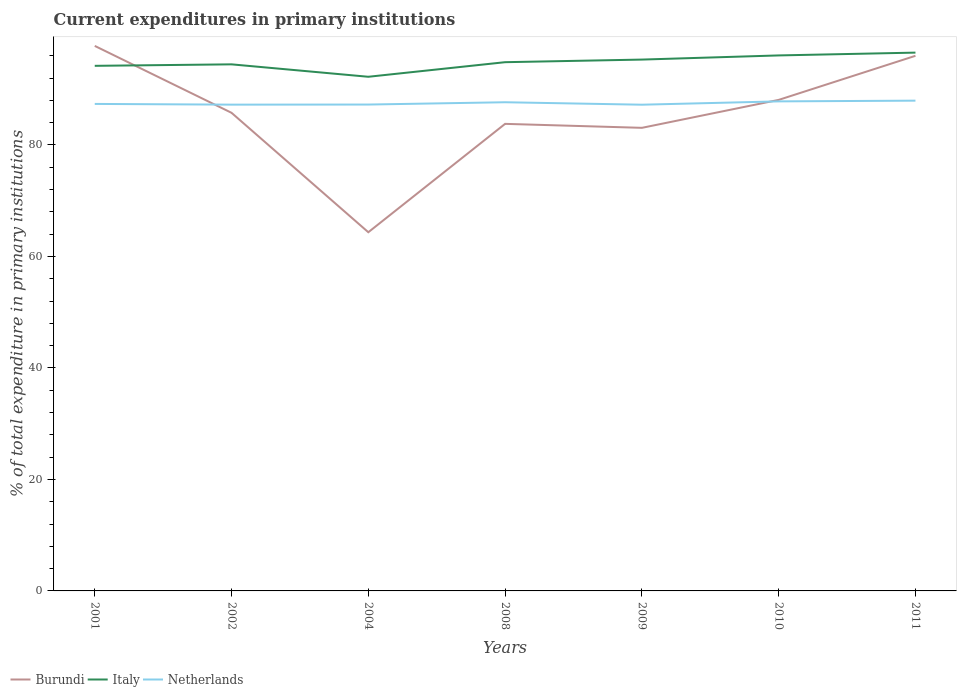Across all years, what is the maximum current expenditures in primary institutions in Burundi?
Give a very brief answer. 64.35. What is the total current expenditures in primary institutions in Burundi in the graph?
Provide a succinct answer. -31.65. What is the difference between the highest and the second highest current expenditures in primary institutions in Italy?
Give a very brief answer. 4.33. How many years are there in the graph?
Offer a terse response. 7. Are the values on the major ticks of Y-axis written in scientific E-notation?
Keep it short and to the point. No. Does the graph contain any zero values?
Provide a short and direct response. No. Does the graph contain grids?
Provide a succinct answer. No. How are the legend labels stacked?
Provide a succinct answer. Horizontal. What is the title of the graph?
Make the answer very short. Current expenditures in primary institutions. What is the label or title of the X-axis?
Offer a very short reply. Years. What is the label or title of the Y-axis?
Your answer should be compact. % of total expenditure in primary institutions. What is the % of total expenditure in primary institutions in Burundi in 2001?
Your answer should be very brief. 97.77. What is the % of total expenditure in primary institutions in Italy in 2001?
Give a very brief answer. 94.2. What is the % of total expenditure in primary institutions of Netherlands in 2001?
Offer a very short reply. 87.36. What is the % of total expenditure in primary institutions of Burundi in 2002?
Provide a short and direct response. 85.77. What is the % of total expenditure in primary institutions of Italy in 2002?
Offer a terse response. 94.46. What is the % of total expenditure in primary institutions in Netherlands in 2002?
Ensure brevity in your answer.  87.24. What is the % of total expenditure in primary institutions of Burundi in 2004?
Your answer should be compact. 64.35. What is the % of total expenditure in primary institutions of Italy in 2004?
Your response must be concise. 92.23. What is the % of total expenditure in primary institutions in Netherlands in 2004?
Your response must be concise. 87.25. What is the % of total expenditure in primary institutions in Burundi in 2008?
Make the answer very short. 83.79. What is the % of total expenditure in primary institutions of Italy in 2008?
Make the answer very short. 94.85. What is the % of total expenditure in primary institutions of Netherlands in 2008?
Offer a very short reply. 87.67. What is the % of total expenditure in primary institutions in Burundi in 2009?
Provide a succinct answer. 83.07. What is the % of total expenditure in primary institutions of Italy in 2009?
Give a very brief answer. 95.32. What is the % of total expenditure in primary institutions in Netherlands in 2009?
Provide a succinct answer. 87.22. What is the % of total expenditure in primary institutions in Burundi in 2010?
Make the answer very short. 88.09. What is the % of total expenditure in primary institutions of Italy in 2010?
Offer a very short reply. 96.07. What is the % of total expenditure in primary institutions in Netherlands in 2010?
Offer a very short reply. 87.82. What is the % of total expenditure in primary institutions in Burundi in 2011?
Offer a very short reply. 96. What is the % of total expenditure in primary institutions of Italy in 2011?
Your answer should be compact. 96.57. What is the % of total expenditure in primary institutions in Netherlands in 2011?
Provide a succinct answer. 87.95. Across all years, what is the maximum % of total expenditure in primary institutions of Burundi?
Give a very brief answer. 97.77. Across all years, what is the maximum % of total expenditure in primary institutions of Italy?
Offer a very short reply. 96.57. Across all years, what is the maximum % of total expenditure in primary institutions in Netherlands?
Provide a short and direct response. 87.95. Across all years, what is the minimum % of total expenditure in primary institutions of Burundi?
Offer a terse response. 64.35. Across all years, what is the minimum % of total expenditure in primary institutions of Italy?
Give a very brief answer. 92.23. Across all years, what is the minimum % of total expenditure in primary institutions in Netherlands?
Provide a short and direct response. 87.22. What is the total % of total expenditure in primary institutions in Burundi in the graph?
Ensure brevity in your answer.  598.84. What is the total % of total expenditure in primary institutions in Italy in the graph?
Keep it short and to the point. 663.7. What is the total % of total expenditure in primary institutions of Netherlands in the graph?
Your answer should be very brief. 612.51. What is the difference between the % of total expenditure in primary institutions of Burundi in 2001 and that in 2002?
Your response must be concise. 12. What is the difference between the % of total expenditure in primary institutions in Italy in 2001 and that in 2002?
Provide a short and direct response. -0.27. What is the difference between the % of total expenditure in primary institutions of Netherlands in 2001 and that in 2002?
Your response must be concise. 0.13. What is the difference between the % of total expenditure in primary institutions in Burundi in 2001 and that in 2004?
Keep it short and to the point. 33.43. What is the difference between the % of total expenditure in primary institutions in Italy in 2001 and that in 2004?
Keep it short and to the point. 1.96. What is the difference between the % of total expenditure in primary institutions of Netherlands in 2001 and that in 2004?
Your answer should be compact. 0.11. What is the difference between the % of total expenditure in primary institutions of Burundi in 2001 and that in 2008?
Provide a short and direct response. 13.99. What is the difference between the % of total expenditure in primary institutions of Italy in 2001 and that in 2008?
Your response must be concise. -0.65. What is the difference between the % of total expenditure in primary institutions in Netherlands in 2001 and that in 2008?
Ensure brevity in your answer.  -0.3. What is the difference between the % of total expenditure in primary institutions in Burundi in 2001 and that in 2009?
Your answer should be compact. 14.7. What is the difference between the % of total expenditure in primary institutions of Italy in 2001 and that in 2009?
Your answer should be very brief. -1.12. What is the difference between the % of total expenditure in primary institutions in Netherlands in 2001 and that in 2009?
Provide a short and direct response. 0.14. What is the difference between the % of total expenditure in primary institutions of Burundi in 2001 and that in 2010?
Give a very brief answer. 9.69. What is the difference between the % of total expenditure in primary institutions in Italy in 2001 and that in 2010?
Offer a very short reply. -1.87. What is the difference between the % of total expenditure in primary institutions in Netherlands in 2001 and that in 2010?
Your response must be concise. -0.46. What is the difference between the % of total expenditure in primary institutions of Burundi in 2001 and that in 2011?
Provide a succinct answer. 1.78. What is the difference between the % of total expenditure in primary institutions in Italy in 2001 and that in 2011?
Give a very brief answer. -2.37. What is the difference between the % of total expenditure in primary institutions in Netherlands in 2001 and that in 2011?
Your answer should be compact. -0.58. What is the difference between the % of total expenditure in primary institutions of Burundi in 2002 and that in 2004?
Ensure brevity in your answer.  21.42. What is the difference between the % of total expenditure in primary institutions of Italy in 2002 and that in 2004?
Give a very brief answer. 2.23. What is the difference between the % of total expenditure in primary institutions in Netherlands in 2002 and that in 2004?
Offer a terse response. -0.02. What is the difference between the % of total expenditure in primary institutions in Burundi in 2002 and that in 2008?
Provide a succinct answer. 1.98. What is the difference between the % of total expenditure in primary institutions of Italy in 2002 and that in 2008?
Give a very brief answer. -0.39. What is the difference between the % of total expenditure in primary institutions of Netherlands in 2002 and that in 2008?
Give a very brief answer. -0.43. What is the difference between the % of total expenditure in primary institutions of Burundi in 2002 and that in 2009?
Keep it short and to the point. 2.7. What is the difference between the % of total expenditure in primary institutions in Italy in 2002 and that in 2009?
Your answer should be compact. -0.85. What is the difference between the % of total expenditure in primary institutions of Netherlands in 2002 and that in 2009?
Offer a very short reply. 0.01. What is the difference between the % of total expenditure in primary institutions in Burundi in 2002 and that in 2010?
Offer a very short reply. -2.32. What is the difference between the % of total expenditure in primary institutions in Italy in 2002 and that in 2010?
Ensure brevity in your answer.  -1.6. What is the difference between the % of total expenditure in primary institutions of Netherlands in 2002 and that in 2010?
Offer a terse response. -0.59. What is the difference between the % of total expenditure in primary institutions of Burundi in 2002 and that in 2011?
Your answer should be very brief. -10.22. What is the difference between the % of total expenditure in primary institutions of Italy in 2002 and that in 2011?
Make the answer very short. -2.1. What is the difference between the % of total expenditure in primary institutions of Netherlands in 2002 and that in 2011?
Your response must be concise. -0.71. What is the difference between the % of total expenditure in primary institutions in Burundi in 2004 and that in 2008?
Your answer should be compact. -19.44. What is the difference between the % of total expenditure in primary institutions in Italy in 2004 and that in 2008?
Provide a short and direct response. -2.62. What is the difference between the % of total expenditure in primary institutions in Netherlands in 2004 and that in 2008?
Make the answer very short. -0.41. What is the difference between the % of total expenditure in primary institutions of Burundi in 2004 and that in 2009?
Ensure brevity in your answer.  -18.73. What is the difference between the % of total expenditure in primary institutions in Italy in 2004 and that in 2009?
Offer a terse response. -3.08. What is the difference between the % of total expenditure in primary institutions of Netherlands in 2004 and that in 2009?
Provide a short and direct response. 0.03. What is the difference between the % of total expenditure in primary institutions of Burundi in 2004 and that in 2010?
Give a very brief answer. -23.74. What is the difference between the % of total expenditure in primary institutions of Italy in 2004 and that in 2010?
Offer a terse response. -3.83. What is the difference between the % of total expenditure in primary institutions in Netherlands in 2004 and that in 2010?
Your response must be concise. -0.57. What is the difference between the % of total expenditure in primary institutions of Burundi in 2004 and that in 2011?
Your answer should be compact. -31.65. What is the difference between the % of total expenditure in primary institutions of Italy in 2004 and that in 2011?
Your answer should be very brief. -4.33. What is the difference between the % of total expenditure in primary institutions in Netherlands in 2004 and that in 2011?
Provide a succinct answer. -0.7. What is the difference between the % of total expenditure in primary institutions in Burundi in 2008 and that in 2009?
Your response must be concise. 0.71. What is the difference between the % of total expenditure in primary institutions in Italy in 2008 and that in 2009?
Provide a short and direct response. -0.47. What is the difference between the % of total expenditure in primary institutions in Netherlands in 2008 and that in 2009?
Give a very brief answer. 0.44. What is the difference between the % of total expenditure in primary institutions in Burundi in 2008 and that in 2010?
Your answer should be compact. -4.3. What is the difference between the % of total expenditure in primary institutions of Italy in 2008 and that in 2010?
Make the answer very short. -1.21. What is the difference between the % of total expenditure in primary institutions in Netherlands in 2008 and that in 2010?
Provide a succinct answer. -0.16. What is the difference between the % of total expenditure in primary institutions of Burundi in 2008 and that in 2011?
Your answer should be very brief. -12.21. What is the difference between the % of total expenditure in primary institutions of Italy in 2008 and that in 2011?
Your response must be concise. -1.72. What is the difference between the % of total expenditure in primary institutions in Netherlands in 2008 and that in 2011?
Offer a terse response. -0.28. What is the difference between the % of total expenditure in primary institutions of Burundi in 2009 and that in 2010?
Your answer should be compact. -5.01. What is the difference between the % of total expenditure in primary institutions of Italy in 2009 and that in 2010?
Provide a short and direct response. -0.75. What is the difference between the % of total expenditure in primary institutions in Netherlands in 2009 and that in 2010?
Give a very brief answer. -0.6. What is the difference between the % of total expenditure in primary institutions of Burundi in 2009 and that in 2011?
Keep it short and to the point. -12.92. What is the difference between the % of total expenditure in primary institutions of Italy in 2009 and that in 2011?
Keep it short and to the point. -1.25. What is the difference between the % of total expenditure in primary institutions of Netherlands in 2009 and that in 2011?
Offer a very short reply. -0.73. What is the difference between the % of total expenditure in primary institutions of Burundi in 2010 and that in 2011?
Offer a very short reply. -7.91. What is the difference between the % of total expenditure in primary institutions of Italy in 2010 and that in 2011?
Your answer should be compact. -0.5. What is the difference between the % of total expenditure in primary institutions in Netherlands in 2010 and that in 2011?
Your answer should be compact. -0.13. What is the difference between the % of total expenditure in primary institutions of Burundi in 2001 and the % of total expenditure in primary institutions of Italy in 2002?
Your answer should be compact. 3.31. What is the difference between the % of total expenditure in primary institutions in Burundi in 2001 and the % of total expenditure in primary institutions in Netherlands in 2002?
Keep it short and to the point. 10.54. What is the difference between the % of total expenditure in primary institutions of Italy in 2001 and the % of total expenditure in primary institutions of Netherlands in 2002?
Provide a short and direct response. 6.96. What is the difference between the % of total expenditure in primary institutions of Burundi in 2001 and the % of total expenditure in primary institutions of Italy in 2004?
Offer a terse response. 5.54. What is the difference between the % of total expenditure in primary institutions in Burundi in 2001 and the % of total expenditure in primary institutions in Netherlands in 2004?
Offer a terse response. 10.52. What is the difference between the % of total expenditure in primary institutions in Italy in 2001 and the % of total expenditure in primary institutions in Netherlands in 2004?
Keep it short and to the point. 6.95. What is the difference between the % of total expenditure in primary institutions of Burundi in 2001 and the % of total expenditure in primary institutions of Italy in 2008?
Provide a succinct answer. 2.92. What is the difference between the % of total expenditure in primary institutions of Burundi in 2001 and the % of total expenditure in primary institutions of Netherlands in 2008?
Your response must be concise. 10.11. What is the difference between the % of total expenditure in primary institutions in Italy in 2001 and the % of total expenditure in primary institutions in Netherlands in 2008?
Provide a succinct answer. 6.53. What is the difference between the % of total expenditure in primary institutions of Burundi in 2001 and the % of total expenditure in primary institutions of Italy in 2009?
Offer a very short reply. 2.46. What is the difference between the % of total expenditure in primary institutions of Burundi in 2001 and the % of total expenditure in primary institutions of Netherlands in 2009?
Your answer should be very brief. 10.55. What is the difference between the % of total expenditure in primary institutions in Italy in 2001 and the % of total expenditure in primary institutions in Netherlands in 2009?
Provide a succinct answer. 6.97. What is the difference between the % of total expenditure in primary institutions in Burundi in 2001 and the % of total expenditure in primary institutions in Italy in 2010?
Your answer should be very brief. 1.71. What is the difference between the % of total expenditure in primary institutions in Burundi in 2001 and the % of total expenditure in primary institutions in Netherlands in 2010?
Your answer should be very brief. 9.95. What is the difference between the % of total expenditure in primary institutions of Italy in 2001 and the % of total expenditure in primary institutions of Netherlands in 2010?
Give a very brief answer. 6.38. What is the difference between the % of total expenditure in primary institutions of Burundi in 2001 and the % of total expenditure in primary institutions of Italy in 2011?
Your answer should be compact. 1.21. What is the difference between the % of total expenditure in primary institutions in Burundi in 2001 and the % of total expenditure in primary institutions in Netherlands in 2011?
Ensure brevity in your answer.  9.82. What is the difference between the % of total expenditure in primary institutions of Italy in 2001 and the % of total expenditure in primary institutions of Netherlands in 2011?
Offer a terse response. 6.25. What is the difference between the % of total expenditure in primary institutions of Burundi in 2002 and the % of total expenditure in primary institutions of Italy in 2004?
Provide a short and direct response. -6.46. What is the difference between the % of total expenditure in primary institutions of Burundi in 2002 and the % of total expenditure in primary institutions of Netherlands in 2004?
Give a very brief answer. -1.48. What is the difference between the % of total expenditure in primary institutions of Italy in 2002 and the % of total expenditure in primary institutions of Netherlands in 2004?
Give a very brief answer. 7.21. What is the difference between the % of total expenditure in primary institutions in Burundi in 2002 and the % of total expenditure in primary institutions in Italy in 2008?
Give a very brief answer. -9.08. What is the difference between the % of total expenditure in primary institutions of Burundi in 2002 and the % of total expenditure in primary institutions of Netherlands in 2008?
Provide a short and direct response. -1.89. What is the difference between the % of total expenditure in primary institutions of Italy in 2002 and the % of total expenditure in primary institutions of Netherlands in 2008?
Offer a very short reply. 6.8. What is the difference between the % of total expenditure in primary institutions in Burundi in 2002 and the % of total expenditure in primary institutions in Italy in 2009?
Keep it short and to the point. -9.55. What is the difference between the % of total expenditure in primary institutions of Burundi in 2002 and the % of total expenditure in primary institutions of Netherlands in 2009?
Your answer should be very brief. -1.45. What is the difference between the % of total expenditure in primary institutions in Italy in 2002 and the % of total expenditure in primary institutions in Netherlands in 2009?
Offer a terse response. 7.24. What is the difference between the % of total expenditure in primary institutions of Burundi in 2002 and the % of total expenditure in primary institutions of Italy in 2010?
Offer a terse response. -10.29. What is the difference between the % of total expenditure in primary institutions in Burundi in 2002 and the % of total expenditure in primary institutions in Netherlands in 2010?
Your answer should be very brief. -2.05. What is the difference between the % of total expenditure in primary institutions in Italy in 2002 and the % of total expenditure in primary institutions in Netherlands in 2010?
Your answer should be compact. 6.64. What is the difference between the % of total expenditure in primary institutions in Burundi in 2002 and the % of total expenditure in primary institutions in Italy in 2011?
Your answer should be compact. -10.8. What is the difference between the % of total expenditure in primary institutions in Burundi in 2002 and the % of total expenditure in primary institutions in Netherlands in 2011?
Provide a succinct answer. -2.18. What is the difference between the % of total expenditure in primary institutions of Italy in 2002 and the % of total expenditure in primary institutions of Netherlands in 2011?
Provide a succinct answer. 6.52. What is the difference between the % of total expenditure in primary institutions of Burundi in 2004 and the % of total expenditure in primary institutions of Italy in 2008?
Provide a short and direct response. -30.5. What is the difference between the % of total expenditure in primary institutions of Burundi in 2004 and the % of total expenditure in primary institutions of Netherlands in 2008?
Provide a succinct answer. -23.32. What is the difference between the % of total expenditure in primary institutions in Italy in 2004 and the % of total expenditure in primary institutions in Netherlands in 2008?
Provide a short and direct response. 4.57. What is the difference between the % of total expenditure in primary institutions of Burundi in 2004 and the % of total expenditure in primary institutions of Italy in 2009?
Provide a short and direct response. -30.97. What is the difference between the % of total expenditure in primary institutions in Burundi in 2004 and the % of total expenditure in primary institutions in Netherlands in 2009?
Your answer should be compact. -22.88. What is the difference between the % of total expenditure in primary institutions in Italy in 2004 and the % of total expenditure in primary institutions in Netherlands in 2009?
Your answer should be compact. 5.01. What is the difference between the % of total expenditure in primary institutions of Burundi in 2004 and the % of total expenditure in primary institutions of Italy in 2010?
Give a very brief answer. -31.72. What is the difference between the % of total expenditure in primary institutions of Burundi in 2004 and the % of total expenditure in primary institutions of Netherlands in 2010?
Your answer should be very brief. -23.47. What is the difference between the % of total expenditure in primary institutions in Italy in 2004 and the % of total expenditure in primary institutions in Netherlands in 2010?
Your response must be concise. 4.41. What is the difference between the % of total expenditure in primary institutions in Burundi in 2004 and the % of total expenditure in primary institutions in Italy in 2011?
Ensure brevity in your answer.  -32.22. What is the difference between the % of total expenditure in primary institutions of Burundi in 2004 and the % of total expenditure in primary institutions of Netherlands in 2011?
Offer a terse response. -23.6. What is the difference between the % of total expenditure in primary institutions in Italy in 2004 and the % of total expenditure in primary institutions in Netherlands in 2011?
Give a very brief answer. 4.28. What is the difference between the % of total expenditure in primary institutions in Burundi in 2008 and the % of total expenditure in primary institutions in Italy in 2009?
Your answer should be compact. -11.53. What is the difference between the % of total expenditure in primary institutions in Burundi in 2008 and the % of total expenditure in primary institutions in Netherlands in 2009?
Ensure brevity in your answer.  -3.44. What is the difference between the % of total expenditure in primary institutions of Italy in 2008 and the % of total expenditure in primary institutions of Netherlands in 2009?
Ensure brevity in your answer.  7.63. What is the difference between the % of total expenditure in primary institutions of Burundi in 2008 and the % of total expenditure in primary institutions of Italy in 2010?
Make the answer very short. -12.28. What is the difference between the % of total expenditure in primary institutions of Burundi in 2008 and the % of total expenditure in primary institutions of Netherlands in 2010?
Your answer should be very brief. -4.03. What is the difference between the % of total expenditure in primary institutions in Italy in 2008 and the % of total expenditure in primary institutions in Netherlands in 2010?
Give a very brief answer. 7.03. What is the difference between the % of total expenditure in primary institutions in Burundi in 2008 and the % of total expenditure in primary institutions in Italy in 2011?
Your answer should be compact. -12.78. What is the difference between the % of total expenditure in primary institutions of Burundi in 2008 and the % of total expenditure in primary institutions of Netherlands in 2011?
Your answer should be compact. -4.16. What is the difference between the % of total expenditure in primary institutions of Italy in 2008 and the % of total expenditure in primary institutions of Netherlands in 2011?
Your answer should be very brief. 6.9. What is the difference between the % of total expenditure in primary institutions of Burundi in 2009 and the % of total expenditure in primary institutions of Italy in 2010?
Your response must be concise. -12.99. What is the difference between the % of total expenditure in primary institutions of Burundi in 2009 and the % of total expenditure in primary institutions of Netherlands in 2010?
Offer a very short reply. -4.75. What is the difference between the % of total expenditure in primary institutions in Italy in 2009 and the % of total expenditure in primary institutions in Netherlands in 2010?
Give a very brief answer. 7.5. What is the difference between the % of total expenditure in primary institutions of Burundi in 2009 and the % of total expenditure in primary institutions of Italy in 2011?
Make the answer very short. -13.49. What is the difference between the % of total expenditure in primary institutions in Burundi in 2009 and the % of total expenditure in primary institutions in Netherlands in 2011?
Give a very brief answer. -4.87. What is the difference between the % of total expenditure in primary institutions in Italy in 2009 and the % of total expenditure in primary institutions in Netherlands in 2011?
Provide a short and direct response. 7.37. What is the difference between the % of total expenditure in primary institutions in Burundi in 2010 and the % of total expenditure in primary institutions in Italy in 2011?
Provide a short and direct response. -8.48. What is the difference between the % of total expenditure in primary institutions in Burundi in 2010 and the % of total expenditure in primary institutions in Netherlands in 2011?
Provide a succinct answer. 0.14. What is the difference between the % of total expenditure in primary institutions of Italy in 2010 and the % of total expenditure in primary institutions of Netherlands in 2011?
Provide a short and direct response. 8.12. What is the average % of total expenditure in primary institutions in Burundi per year?
Offer a very short reply. 85.55. What is the average % of total expenditure in primary institutions of Italy per year?
Offer a very short reply. 94.81. What is the average % of total expenditure in primary institutions of Netherlands per year?
Provide a short and direct response. 87.5. In the year 2001, what is the difference between the % of total expenditure in primary institutions in Burundi and % of total expenditure in primary institutions in Italy?
Offer a very short reply. 3.58. In the year 2001, what is the difference between the % of total expenditure in primary institutions in Burundi and % of total expenditure in primary institutions in Netherlands?
Offer a very short reply. 10.41. In the year 2001, what is the difference between the % of total expenditure in primary institutions in Italy and % of total expenditure in primary institutions in Netherlands?
Give a very brief answer. 6.83. In the year 2002, what is the difference between the % of total expenditure in primary institutions in Burundi and % of total expenditure in primary institutions in Italy?
Ensure brevity in your answer.  -8.69. In the year 2002, what is the difference between the % of total expenditure in primary institutions of Burundi and % of total expenditure in primary institutions of Netherlands?
Offer a very short reply. -1.46. In the year 2002, what is the difference between the % of total expenditure in primary institutions in Italy and % of total expenditure in primary institutions in Netherlands?
Give a very brief answer. 7.23. In the year 2004, what is the difference between the % of total expenditure in primary institutions of Burundi and % of total expenditure in primary institutions of Italy?
Make the answer very short. -27.89. In the year 2004, what is the difference between the % of total expenditure in primary institutions of Burundi and % of total expenditure in primary institutions of Netherlands?
Your answer should be compact. -22.9. In the year 2004, what is the difference between the % of total expenditure in primary institutions in Italy and % of total expenditure in primary institutions in Netherlands?
Offer a very short reply. 4.98. In the year 2008, what is the difference between the % of total expenditure in primary institutions in Burundi and % of total expenditure in primary institutions in Italy?
Make the answer very short. -11.06. In the year 2008, what is the difference between the % of total expenditure in primary institutions in Burundi and % of total expenditure in primary institutions in Netherlands?
Provide a succinct answer. -3.88. In the year 2008, what is the difference between the % of total expenditure in primary institutions in Italy and % of total expenditure in primary institutions in Netherlands?
Provide a short and direct response. 7.19. In the year 2009, what is the difference between the % of total expenditure in primary institutions of Burundi and % of total expenditure in primary institutions of Italy?
Keep it short and to the point. -12.24. In the year 2009, what is the difference between the % of total expenditure in primary institutions in Burundi and % of total expenditure in primary institutions in Netherlands?
Provide a succinct answer. -4.15. In the year 2009, what is the difference between the % of total expenditure in primary institutions of Italy and % of total expenditure in primary institutions of Netherlands?
Keep it short and to the point. 8.09. In the year 2010, what is the difference between the % of total expenditure in primary institutions of Burundi and % of total expenditure in primary institutions of Italy?
Offer a terse response. -7.98. In the year 2010, what is the difference between the % of total expenditure in primary institutions in Burundi and % of total expenditure in primary institutions in Netherlands?
Keep it short and to the point. 0.27. In the year 2010, what is the difference between the % of total expenditure in primary institutions of Italy and % of total expenditure in primary institutions of Netherlands?
Ensure brevity in your answer.  8.24. In the year 2011, what is the difference between the % of total expenditure in primary institutions in Burundi and % of total expenditure in primary institutions in Italy?
Make the answer very short. -0.57. In the year 2011, what is the difference between the % of total expenditure in primary institutions of Burundi and % of total expenditure in primary institutions of Netherlands?
Your answer should be very brief. 8.05. In the year 2011, what is the difference between the % of total expenditure in primary institutions of Italy and % of total expenditure in primary institutions of Netherlands?
Your answer should be very brief. 8.62. What is the ratio of the % of total expenditure in primary institutions of Burundi in 2001 to that in 2002?
Give a very brief answer. 1.14. What is the ratio of the % of total expenditure in primary institutions of Netherlands in 2001 to that in 2002?
Make the answer very short. 1. What is the ratio of the % of total expenditure in primary institutions in Burundi in 2001 to that in 2004?
Make the answer very short. 1.52. What is the ratio of the % of total expenditure in primary institutions in Italy in 2001 to that in 2004?
Provide a succinct answer. 1.02. What is the ratio of the % of total expenditure in primary institutions in Netherlands in 2001 to that in 2004?
Ensure brevity in your answer.  1. What is the ratio of the % of total expenditure in primary institutions in Burundi in 2001 to that in 2008?
Offer a very short reply. 1.17. What is the ratio of the % of total expenditure in primary institutions of Italy in 2001 to that in 2008?
Offer a very short reply. 0.99. What is the ratio of the % of total expenditure in primary institutions in Burundi in 2001 to that in 2009?
Your answer should be very brief. 1.18. What is the ratio of the % of total expenditure in primary institutions in Italy in 2001 to that in 2009?
Provide a short and direct response. 0.99. What is the ratio of the % of total expenditure in primary institutions in Burundi in 2001 to that in 2010?
Give a very brief answer. 1.11. What is the ratio of the % of total expenditure in primary institutions in Italy in 2001 to that in 2010?
Keep it short and to the point. 0.98. What is the ratio of the % of total expenditure in primary institutions of Burundi in 2001 to that in 2011?
Provide a short and direct response. 1.02. What is the ratio of the % of total expenditure in primary institutions of Italy in 2001 to that in 2011?
Ensure brevity in your answer.  0.98. What is the ratio of the % of total expenditure in primary institutions of Netherlands in 2001 to that in 2011?
Your answer should be very brief. 0.99. What is the ratio of the % of total expenditure in primary institutions in Burundi in 2002 to that in 2004?
Offer a terse response. 1.33. What is the ratio of the % of total expenditure in primary institutions of Italy in 2002 to that in 2004?
Give a very brief answer. 1.02. What is the ratio of the % of total expenditure in primary institutions in Netherlands in 2002 to that in 2004?
Offer a very short reply. 1. What is the ratio of the % of total expenditure in primary institutions of Burundi in 2002 to that in 2008?
Keep it short and to the point. 1.02. What is the ratio of the % of total expenditure in primary institutions of Burundi in 2002 to that in 2009?
Your response must be concise. 1.03. What is the ratio of the % of total expenditure in primary institutions in Italy in 2002 to that in 2009?
Your answer should be compact. 0.99. What is the ratio of the % of total expenditure in primary institutions of Burundi in 2002 to that in 2010?
Give a very brief answer. 0.97. What is the ratio of the % of total expenditure in primary institutions in Italy in 2002 to that in 2010?
Your answer should be compact. 0.98. What is the ratio of the % of total expenditure in primary institutions of Burundi in 2002 to that in 2011?
Offer a very short reply. 0.89. What is the ratio of the % of total expenditure in primary institutions in Italy in 2002 to that in 2011?
Offer a very short reply. 0.98. What is the ratio of the % of total expenditure in primary institutions in Netherlands in 2002 to that in 2011?
Make the answer very short. 0.99. What is the ratio of the % of total expenditure in primary institutions in Burundi in 2004 to that in 2008?
Offer a terse response. 0.77. What is the ratio of the % of total expenditure in primary institutions of Italy in 2004 to that in 2008?
Your answer should be compact. 0.97. What is the ratio of the % of total expenditure in primary institutions of Burundi in 2004 to that in 2009?
Your answer should be compact. 0.77. What is the ratio of the % of total expenditure in primary institutions of Italy in 2004 to that in 2009?
Your answer should be very brief. 0.97. What is the ratio of the % of total expenditure in primary institutions in Burundi in 2004 to that in 2010?
Ensure brevity in your answer.  0.73. What is the ratio of the % of total expenditure in primary institutions of Italy in 2004 to that in 2010?
Provide a short and direct response. 0.96. What is the ratio of the % of total expenditure in primary institutions in Netherlands in 2004 to that in 2010?
Offer a terse response. 0.99. What is the ratio of the % of total expenditure in primary institutions of Burundi in 2004 to that in 2011?
Ensure brevity in your answer.  0.67. What is the ratio of the % of total expenditure in primary institutions in Italy in 2004 to that in 2011?
Offer a very short reply. 0.96. What is the ratio of the % of total expenditure in primary institutions in Burundi in 2008 to that in 2009?
Offer a very short reply. 1.01. What is the ratio of the % of total expenditure in primary institutions of Burundi in 2008 to that in 2010?
Provide a short and direct response. 0.95. What is the ratio of the % of total expenditure in primary institutions in Italy in 2008 to that in 2010?
Your answer should be very brief. 0.99. What is the ratio of the % of total expenditure in primary institutions in Burundi in 2008 to that in 2011?
Offer a very short reply. 0.87. What is the ratio of the % of total expenditure in primary institutions of Italy in 2008 to that in 2011?
Give a very brief answer. 0.98. What is the ratio of the % of total expenditure in primary institutions in Netherlands in 2008 to that in 2011?
Give a very brief answer. 1. What is the ratio of the % of total expenditure in primary institutions of Burundi in 2009 to that in 2010?
Make the answer very short. 0.94. What is the ratio of the % of total expenditure in primary institutions in Italy in 2009 to that in 2010?
Your answer should be very brief. 0.99. What is the ratio of the % of total expenditure in primary institutions of Netherlands in 2009 to that in 2010?
Provide a short and direct response. 0.99. What is the ratio of the % of total expenditure in primary institutions in Burundi in 2009 to that in 2011?
Your answer should be compact. 0.87. What is the ratio of the % of total expenditure in primary institutions in Italy in 2009 to that in 2011?
Offer a very short reply. 0.99. What is the ratio of the % of total expenditure in primary institutions of Netherlands in 2009 to that in 2011?
Your answer should be compact. 0.99. What is the ratio of the % of total expenditure in primary institutions of Burundi in 2010 to that in 2011?
Offer a terse response. 0.92. What is the difference between the highest and the second highest % of total expenditure in primary institutions of Burundi?
Your answer should be very brief. 1.78. What is the difference between the highest and the second highest % of total expenditure in primary institutions of Italy?
Offer a terse response. 0.5. What is the difference between the highest and the second highest % of total expenditure in primary institutions of Netherlands?
Keep it short and to the point. 0.13. What is the difference between the highest and the lowest % of total expenditure in primary institutions of Burundi?
Ensure brevity in your answer.  33.43. What is the difference between the highest and the lowest % of total expenditure in primary institutions in Italy?
Your answer should be very brief. 4.33. What is the difference between the highest and the lowest % of total expenditure in primary institutions of Netherlands?
Make the answer very short. 0.73. 